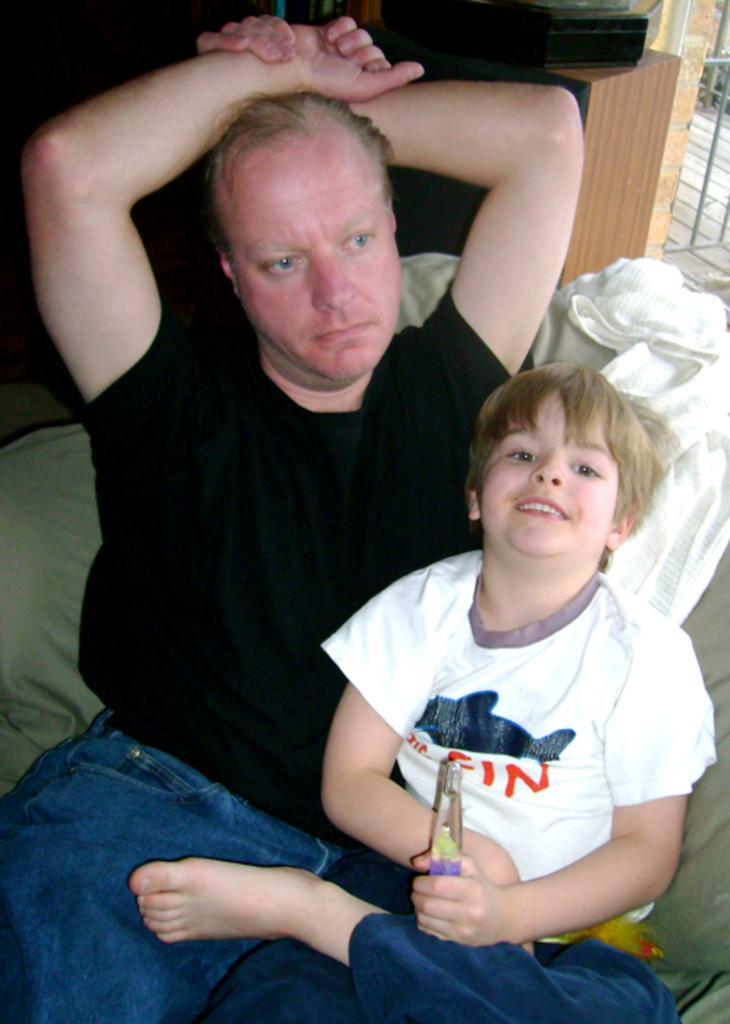In one or two sentences, can you explain what this image depicts? In this image, we can see people sitting on the sofa and one of them is holding an object. In the background, there is an object on the stand and we can see a railing. 